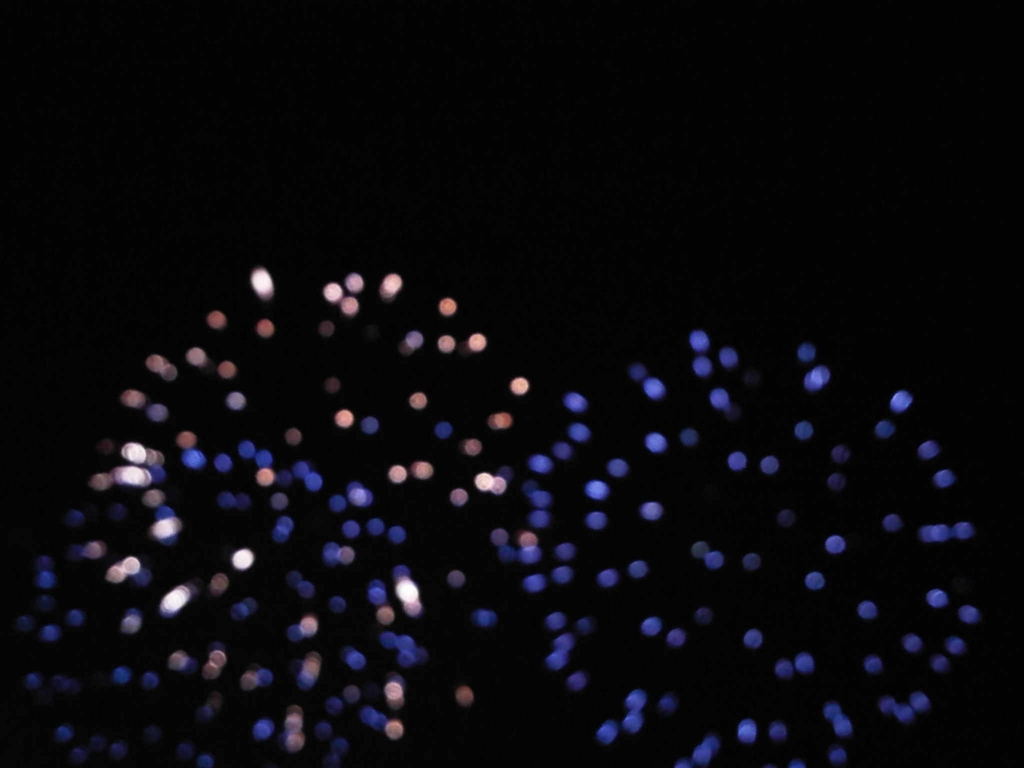Can you describe what the image portrays or suggest what it might be? The image appears to capture bokeh light effects, characterized by the orbs of light against a dark background. Without more context or clarity it's challenging to specify the exact source, but this could be a photograph of distant city lights or perhaps light reflections on water taken with a camera set to a shallow depth of field. 